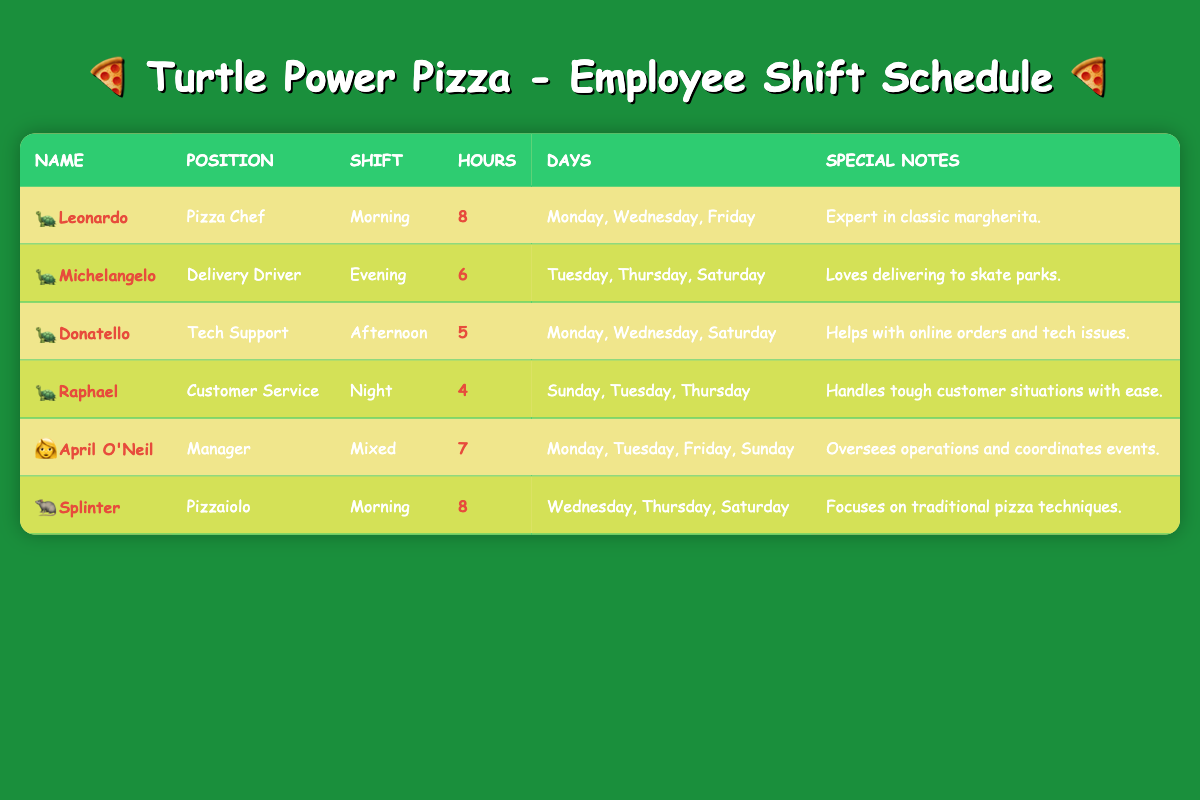What is the total number of hours worked by Leonardo in a week? Leonardo works 8 hours per day and works on 3 days (Monday, Wednesday, and Friday), so the total hours worked is 8 * 3 = 24.
Answer: 24 How many shifts does April O'Neil work in a week? April O'Neil works a mixed shift and works on 4 days (Monday, Tuesday, Friday, and Sunday), so she has 4 shifts in a week.
Answer: 4 What position has the fewest hours worked per week? Raphael works 4 hours per day and works on 3 days (Sunday, Tuesday, and Thursday), resulting in a total of 4 * 3 = 12 hours. This is fewer than the other employees' total hours, which are all greater.
Answer: Raphael Is Michelangelo's position related to customer service? Michelangelo is a Delivery Driver and not in customer service, so this statement is false.
Answer: No How many employees work morning shifts? Leonardo and Splinter both work morning shifts. This gives us a total of 2 employees working in the morning.
Answer: 2 What is the total number of hours worked by employees in the Night shift? Raphael works for 4 hours on 3 days (Sunday, Tuesday, and Thursday). Thus, the total hours are 4 * 3 = 12.
Answer: 12 Who works the most hours among all employees? Leonardo and Splinter both work 8 hours each on their respective shifts, which is the highest among all employees.
Answer: Leonardo and Splinter How many shifts does Donatello work in a week? Donatello works on 3 days (Monday, Wednesday, and Saturday), giving him 3 shifts in a week.
Answer: 3 What is the average number of hours worked by employees in the Afternoon shift? Donatello works 5 hours in the Afternoon shift and works for 1 day (Monday, Wednesday, Saturday), so average is 5/1 = 5.
Answer: 5 Does any employee work on Saturday? Michelangelo, Donatello, and Splinter all work on Saturday, so the statement is true.
Answer: Yes Which two employees work in the same days on their shifts? Leonardo works Monday, Wednesday, and Friday, while Donatello works Monday, Wednesday, and Saturday, so they share 2 days, which is Monday and Wednesday.
Answer: Leonardo and Donatello 